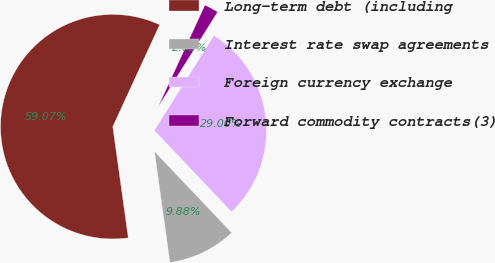Convert chart to OTSL. <chart><loc_0><loc_0><loc_500><loc_500><pie_chart><fcel>Long-term debt (including<fcel>Interest rate swap agreements<fcel>Foreign currency exchange<fcel>Forward commodity contracts(3)<nl><fcel>59.07%<fcel>9.88%<fcel>29.0%<fcel>2.05%<nl></chart> 